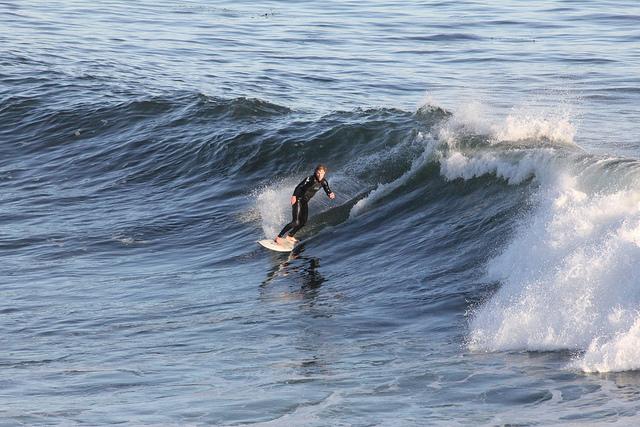Is the dog surfing?
Give a very brief answer. No. Is it daytime?
Short answer required. Yes. What color is the surfer's board?
Give a very brief answer. White. What color is the surfboard?
Concise answer only. White. Is anyone swimming?
Be succinct. No. How many surfers are on their surfboards?
Concise answer only. 1. How big is the wave?
Be succinct. 7 feet. 